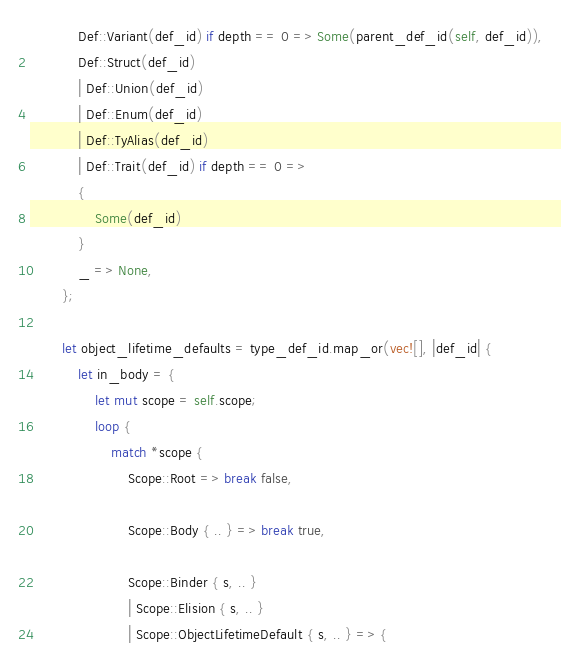Convert code to text. <code><loc_0><loc_0><loc_500><loc_500><_Rust_>            Def::Variant(def_id) if depth == 0 => Some(parent_def_id(self, def_id)),
            Def::Struct(def_id)
            | Def::Union(def_id)
            | Def::Enum(def_id)
            | Def::TyAlias(def_id)
            | Def::Trait(def_id) if depth == 0 =>
            {
                Some(def_id)
            }
            _ => None,
        };

        let object_lifetime_defaults = type_def_id.map_or(vec![], |def_id| {
            let in_body = {
                let mut scope = self.scope;
                loop {
                    match *scope {
                        Scope::Root => break false,

                        Scope::Body { .. } => break true,

                        Scope::Binder { s, .. }
                        | Scope::Elision { s, .. }
                        | Scope::ObjectLifetimeDefault { s, .. } => {</code> 